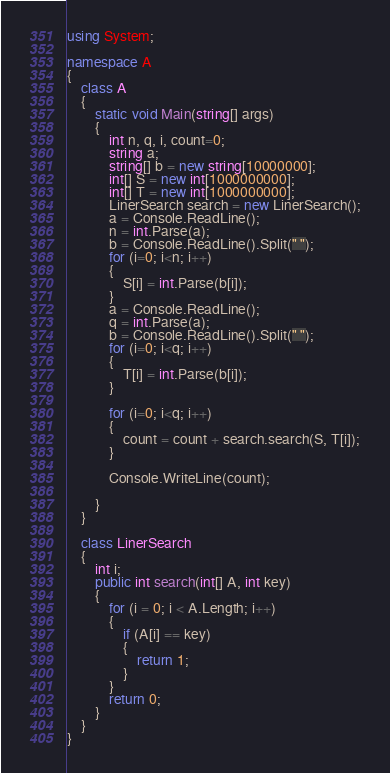Convert code to text. <code><loc_0><loc_0><loc_500><loc_500><_C#_>using System;

namespace A
{
    class A
    {
        static void Main(string[] args)
        {
            int n, q, i, count=0;
            string a;
            string[] b = new string[10000000];
            int[] S = new int[1000000000];
            int[] T = new int[1000000000];
            LinerSearch search = new LinerSearch();
            a = Console.ReadLine();
            n = int.Parse(a);
            b = Console.ReadLine().Split(" ");
            for (i=0; i<n; i++)
            {
                S[i] = int.Parse(b[i]);
            }
            a = Console.ReadLine();
            q = int.Parse(a);
            b = Console.ReadLine().Split(" ");
            for (i=0; i<q; i++)
            {
                T[i] = int.Parse(b[i]);
            }

            for (i=0; i<q; i++)
            {
                count = count + search.search(S, T[i]);
            }

            Console.WriteLine(count);
            
        }
    }

    class LinerSearch
    {
        int i;
        public int search(int[] A, int key)
        {
            for (i = 0; i < A.Length; i++)
            {
                if (A[i] == key)
                {
                    return 1;
                }
            }
            return 0;
        }
    }
}

</code> 